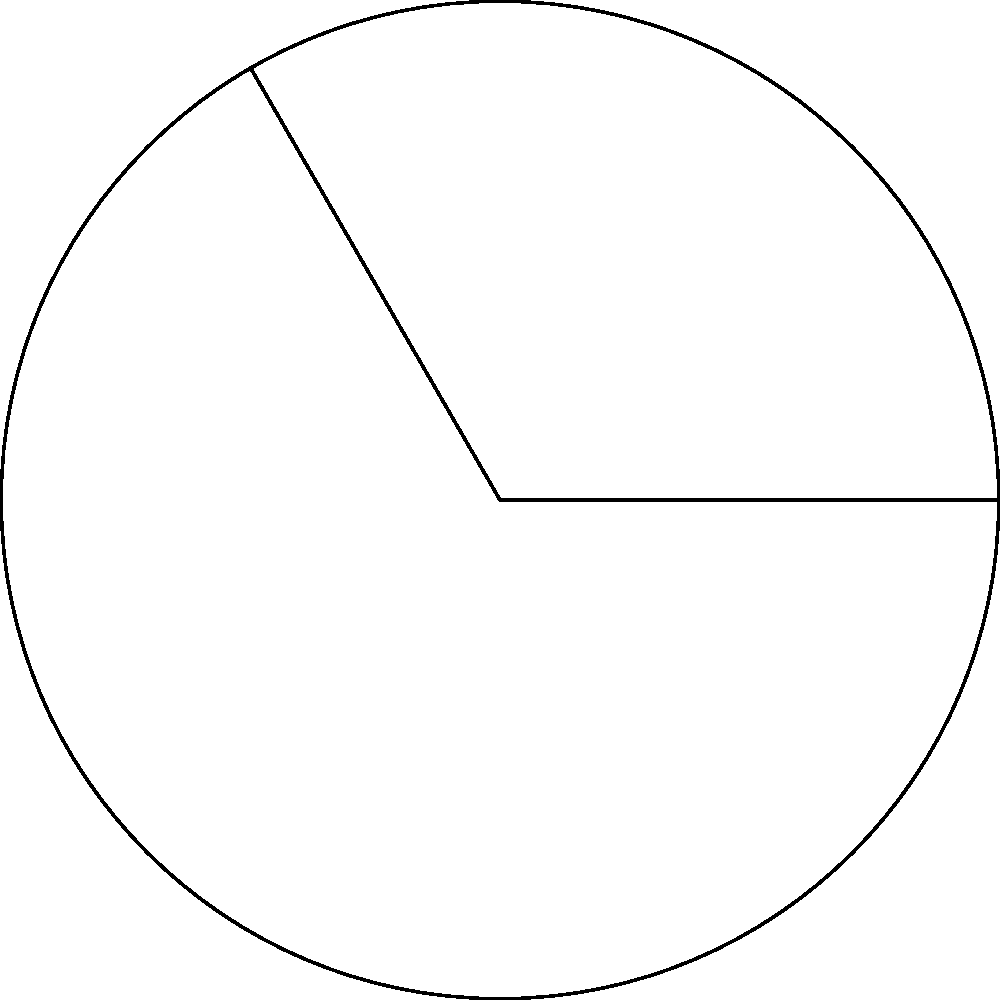In the context of designing an AI assistant that understands user behavior, consider a circular interface element. If this element has a radius of 10 cm and a central angle of 120°, what is the area of the resulting circular sector? How might this information be relevant to user experience design? To find the area of a circular sector, we'll follow these steps:

1) The formula for the area of a circular sector is:
   $$A = \frac{1}{2}r^2\theta$$
   Where $r$ is the radius and $\theta$ is the central angle in radians.

2) We're given the radius $r = 10$ cm and the angle in degrees (120°).

3) Convert the angle to radians:
   $$\theta = 120° \times \frac{\pi}{180°} = \frac{2\pi}{3} \approx 2.0944 \text{ radians}$$

4) Now substitute into the formula:
   $$A = \frac{1}{2} \times 10^2 \times \frac{2\pi}{3}$$

5) Simplify:
   $$A = \frac{100\pi}{3} \approx 104.72 \text{ cm}^2$$

In UX design, understanding the area of circular sectors could be crucial for designing intuitive radial menus or progress indicators. The size of the sector affects visibility and ease of interaction, which directly impacts user experience.
Answer: $\frac{100\pi}{3} \text{ cm}^2$ or approximately 104.72 cm² 